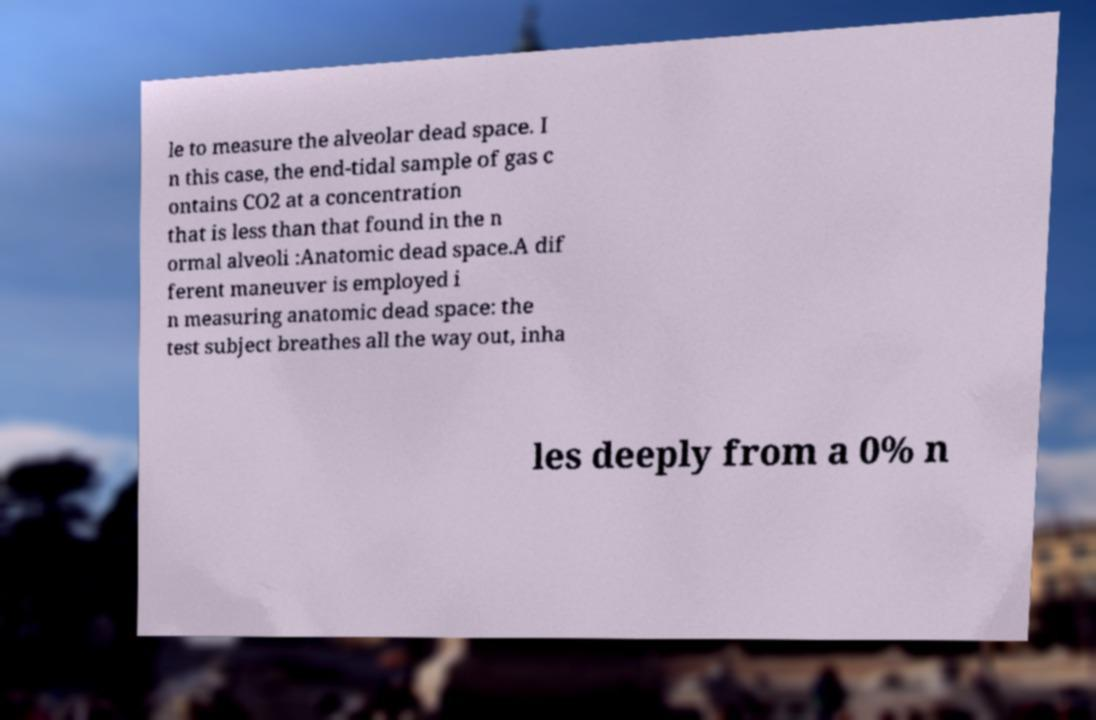I need the written content from this picture converted into text. Can you do that? le to measure the alveolar dead space. I n this case, the end-tidal sample of gas c ontains CO2 at a concentration that is less than that found in the n ormal alveoli :Anatomic dead space.A dif ferent maneuver is employed i n measuring anatomic dead space: the test subject breathes all the way out, inha les deeply from a 0% n 